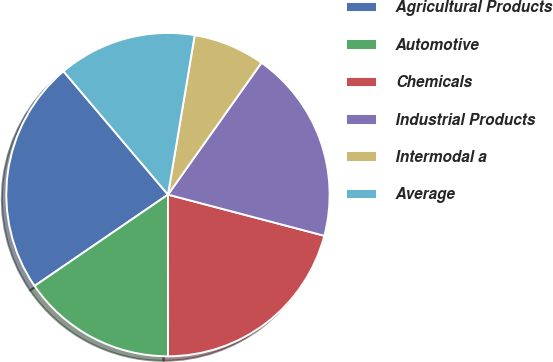Convert chart. <chart><loc_0><loc_0><loc_500><loc_500><pie_chart><fcel>Agricultural Products<fcel>Automotive<fcel>Chemicals<fcel>Industrial Products<fcel>Intermodal a<fcel>Average<nl><fcel>23.37%<fcel>15.45%<fcel>20.9%<fcel>19.28%<fcel>7.17%<fcel>13.83%<nl></chart> 